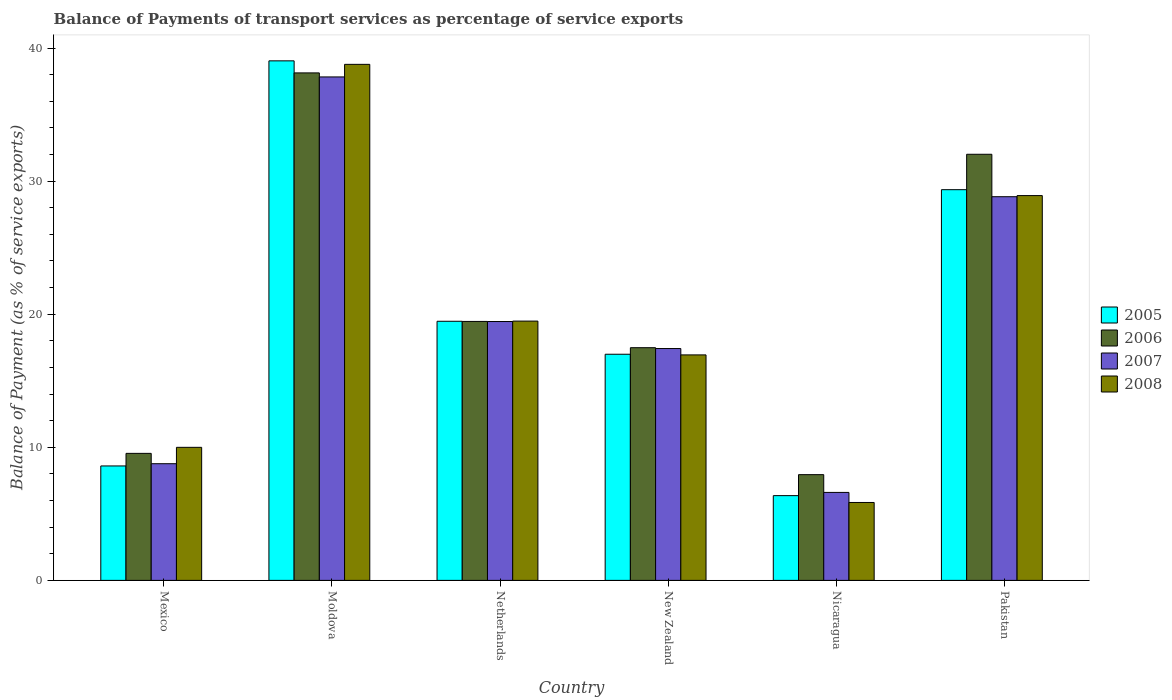How many different coloured bars are there?
Ensure brevity in your answer.  4. How many groups of bars are there?
Your response must be concise. 6. Are the number of bars per tick equal to the number of legend labels?
Make the answer very short. Yes. How many bars are there on the 1st tick from the left?
Your answer should be very brief. 4. What is the balance of payments of transport services in 2006 in Pakistan?
Provide a succinct answer. 32.02. Across all countries, what is the maximum balance of payments of transport services in 2006?
Your answer should be compact. 38.13. Across all countries, what is the minimum balance of payments of transport services in 2007?
Your answer should be compact. 6.61. In which country was the balance of payments of transport services in 2006 maximum?
Give a very brief answer. Moldova. In which country was the balance of payments of transport services in 2005 minimum?
Make the answer very short. Nicaragua. What is the total balance of payments of transport services in 2005 in the graph?
Your answer should be very brief. 119.83. What is the difference between the balance of payments of transport services in 2006 in New Zealand and that in Nicaragua?
Offer a terse response. 9.54. What is the difference between the balance of payments of transport services in 2005 in New Zealand and the balance of payments of transport services in 2006 in Moldova?
Provide a short and direct response. -21.14. What is the average balance of payments of transport services in 2007 per country?
Keep it short and to the point. 19.82. What is the difference between the balance of payments of transport services of/in 2008 and balance of payments of transport services of/in 2007 in Moldova?
Your response must be concise. 0.95. What is the ratio of the balance of payments of transport services in 2008 in Moldova to that in Pakistan?
Your answer should be very brief. 1.34. Is the balance of payments of transport services in 2006 in Moldova less than that in Netherlands?
Give a very brief answer. No. Is the difference between the balance of payments of transport services in 2008 in Moldova and Pakistan greater than the difference between the balance of payments of transport services in 2007 in Moldova and Pakistan?
Ensure brevity in your answer.  Yes. What is the difference between the highest and the second highest balance of payments of transport services in 2005?
Provide a succinct answer. -9.89. What is the difference between the highest and the lowest balance of payments of transport services in 2005?
Your response must be concise. 32.67. In how many countries, is the balance of payments of transport services in 2007 greater than the average balance of payments of transport services in 2007 taken over all countries?
Offer a very short reply. 2. Are all the bars in the graph horizontal?
Your answer should be very brief. No. How many countries are there in the graph?
Your answer should be very brief. 6. What is the difference between two consecutive major ticks on the Y-axis?
Offer a very short reply. 10. Are the values on the major ticks of Y-axis written in scientific E-notation?
Your response must be concise. No. Does the graph contain grids?
Make the answer very short. No. Where does the legend appear in the graph?
Ensure brevity in your answer.  Center right. How many legend labels are there?
Provide a succinct answer. 4. How are the legend labels stacked?
Offer a terse response. Vertical. What is the title of the graph?
Your answer should be very brief. Balance of Payments of transport services as percentage of service exports. What is the label or title of the Y-axis?
Provide a short and direct response. Balance of Payment (as % of service exports). What is the Balance of Payment (as % of service exports) in 2005 in Mexico?
Provide a succinct answer. 8.6. What is the Balance of Payment (as % of service exports) in 2006 in Mexico?
Ensure brevity in your answer.  9.54. What is the Balance of Payment (as % of service exports) of 2007 in Mexico?
Offer a terse response. 8.77. What is the Balance of Payment (as % of service exports) in 2008 in Mexico?
Ensure brevity in your answer.  10. What is the Balance of Payment (as % of service exports) of 2005 in Moldova?
Make the answer very short. 39.04. What is the Balance of Payment (as % of service exports) in 2006 in Moldova?
Your answer should be very brief. 38.13. What is the Balance of Payment (as % of service exports) in 2007 in Moldova?
Keep it short and to the point. 37.83. What is the Balance of Payment (as % of service exports) of 2008 in Moldova?
Your answer should be compact. 38.78. What is the Balance of Payment (as % of service exports) in 2005 in Netherlands?
Your answer should be compact. 19.47. What is the Balance of Payment (as % of service exports) in 2006 in Netherlands?
Offer a very short reply. 19.46. What is the Balance of Payment (as % of service exports) of 2007 in Netherlands?
Keep it short and to the point. 19.45. What is the Balance of Payment (as % of service exports) in 2008 in Netherlands?
Provide a short and direct response. 19.48. What is the Balance of Payment (as % of service exports) of 2005 in New Zealand?
Provide a short and direct response. 16.99. What is the Balance of Payment (as % of service exports) in 2006 in New Zealand?
Make the answer very short. 17.48. What is the Balance of Payment (as % of service exports) in 2007 in New Zealand?
Your response must be concise. 17.42. What is the Balance of Payment (as % of service exports) of 2008 in New Zealand?
Make the answer very short. 16.94. What is the Balance of Payment (as % of service exports) of 2005 in Nicaragua?
Offer a terse response. 6.37. What is the Balance of Payment (as % of service exports) in 2006 in Nicaragua?
Offer a very short reply. 7.95. What is the Balance of Payment (as % of service exports) in 2007 in Nicaragua?
Your answer should be compact. 6.61. What is the Balance of Payment (as % of service exports) in 2008 in Nicaragua?
Offer a terse response. 5.85. What is the Balance of Payment (as % of service exports) of 2005 in Pakistan?
Keep it short and to the point. 29.36. What is the Balance of Payment (as % of service exports) of 2006 in Pakistan?
Keep it short and to the point. 32.02. What is the Balance of Payment (as % of service exports) of 2007 in Pakistan?
Offer a very short reply. 28.83. What is the Balance of Payment (as % of service exports) in 2008 in Pakistan?
Give a very brief answer. 28.91. Across all countries, what is the maximum Balance of Payment (as % of service exports) in 2005?
Keep it short and to the point. 39.04. Across all countries, what is the maximum Balance of Payment (as % of service exports) in 2006?
Your response must be concise. 38.13. Across all countries, what is the maximum Balance of Payment (as % of service exports) of 2007?
Offer a terse response. 37.83. Across all countries, what is the maximum Balance of Payment (as % of service exports) of 2008?
Keep it short and to the point. 38.78. Across all countries, what is the minimum Balance of Payment (as % of service exports) of 2005?
Your response must be concise. 6.37. Across all countries, what is the minimum Balance of Payment (as % of service exports) of 2006?
Give a very brief answer. 7.95. Across all countries, what is the minimum Balance of Payment (as % of service exports) in 2007?
Your answer should be compact. 6.61. Across all countries, what is the minimum Balance of Payment (as % of service exports) of 2008?
Keep it short and to the point. 5.85. What is the total Balance of Payment (as % of service exports) of 2005 in the graph?
Your response must be concise. 119.83. What is the total Balance of Payment (as % of service exports) of 2006 in the graph?
Give a very brief answer. 124.59. What is the total Balance of Payment (as % of service exports) of 2007 in the graph?
Ensure brevity in your answer.  118.91. What is the total Balance of Payment (as % of service exports) of 2008 in the graph?
Your answer should be very brief. 119.97. What is the difference between the Balance of Payment (as % of service exports) in 2005 in Mexico and that in Moldova?
Give a very brief answer. -30.44. What is the difference between the Balance of Payment (as % of service exports) of 2006 in Mexico and that in Moldova?
Give a very brief answer. -28.59. What is the difference between the Balance of Payment (as % of service exports) of 2007 in Mexico and that in Moldova?
Provide a short and direct response. -29.06. What is the difference between the Balance of Payment (as % of service exports) in 2008 in Mexico and that in Moldova?
Your answer should be very brief. -28.78. What is the difference between the Balance of Payment (as % of service exports) of 2005 in Mexico and that in Netherlands?
Provide a succinct answer. -10.87. What is the difference between the Balance of Payment (as % of service exports) in 2006 in Mexico and that in Netherlands?
Ensure brevity in your answer.  -9.91. What is the difference between the Balance of Payment (as % of service exports) of 2007 in Mexico and that in Netherlands?
Offer a very short reply. -10.68. What is the difference between the Balance of Payment (as % of service exports) of 2008 in Mexico and that in Netherlands?
Give a very brief answer. -9.49. What is the difference between the Balance of Payment (as % of service exports) in 2005 in Mexico and that in New Zealand?
Make the answer very short. -8.39. What is the difference between the Balance of Payment (as % of service exports) of 2006 in Mexico and that in New Zealand?
Offer a terse response. -7.94. What is the difference between the Balance of Payment (as % of service exports) of 2007 in Mexico and that in New Zealand?
Offer a very short reply. -8.65. What is the difference between the Balance of Payment (as % of service exports) of 2008 in Mexico and that in New Zealand?
Make the answer very short. -6.95. What is the difference between the Balance of Payment (as % of service exports) of 2005 in Mexico and that in Nicaragua?
Keep it short and to the point. 2.23. What is the difference between the Balance of Payment (as % of service exports) in 2006 in Mexico and that in Nicaragua?
Your response must be concise. 1.6. What is the difference between the Balance of Payment (as % of service exports) in 2007 in Mexico and that in Nicaragua?
Keep it short and to the point. 2.16. What is the difference between the Balance of Payment (as % of service exports) of 2008 in Mexico and that in Nicaragua?
Give a very brief answer. 4.14. What is the difference between the Balance of Payment (as % of service exports) of 2005 in Mexico and that in Pakistan?
Offer a very short reply. -20.76. What is the difference between the Balance of Payment (as % of service exports) in 2006 in Mexico and that in Pakistan?
Keep it short and to the point. -22.47. What is the difference between the Balance of Payment (as % of service exports) of 2007 in Mexico and that in Pakistan?
Make the answer very short. -20.06. What is the difference between the Balance of Payment (as % of service exports) in 2008 in Mexico and that in Pakistan?
Your answer should be compact. -18.92. What is the difference between the Balance of Payment (as % of service exports) of 2005 in Moldova and that in Netherlands?
Ensure brevity in your answer.  19.57. What is the difference between the Balance of Payment (as % of service exports) of 2006 in Moldova and that in Netherlands?
Provide a succinct answer. 18.67. What is the difference between the Balance of Payment (as % of service exports) of 2007 in Moldova and that in Netherlands?
Your answer should be compact. 18.38. What is the difference between the Balance of Payment (as % of service exports) of 2008 in Moldova and that in Netherlands?
Offer a very short reply. 19.29. What is the difference between the Balance of Payment (as % of service exports) in 2005 in Moldova and that in New Zealand?
Make the answer very short. 22.05. What is the difference between the Balance of Payment (as % of service exports) of 2006 in Moldova and that in New Zealand?
Your response must be concise. 20.65. What is the difference between the Balance of Payment (as % of service exports) of 2007 in Moldova and that in New Zealand?
Your response must be concise. 20.41. What is the difference between the Balance of Payment (as % of service exports) in 2008 in Moldova and that in New Zealand?
Your answer should be very brief. 21.83. What is the difference between the Balance of Payment (as % of service exports) of 2005 in Moldova and that in Nicaragua?
Your answer should be compact. 32.67. What is the difference between the Balance of Payment (as % of service exports) in 2006 in Moldova and that in Nicaragua?
Ensure brevity in your answer.  30.19. What is the difference between the Balance of Payment (as % of service exports) in 2007 in Moldova and that in Nicaragua?
Offer a very short reply. 31.22. What is the difference between the Balance of Payment (as % of service exports) of 2008 in Moldova and that in Nicaragua?
Make the answer very short. 32.92. What is the difference between the Balance of Payment (as % of service exports) of 2005 in Moldova and that in Pakistan?
Offer a very short reply. 9.68. What is the difference between the Balance of Payment (as % of service exports) in 2006 in Moldova and that in Pakistan?
Give a very brief answer. 6.11. What is the difference between the Balance of Payment (as % of service exports) of 2007 in Moldova and that in Pakistan?
Offer a terse response. 9. What is the difference between the Balance of Payment (as % of service exports) of 2008 in Moldova and that in Pakistan?
Give a very brief answer. 9.86. What is the difference between the Balance of Payment (as % of service exports) of 2005 in Netherlands and that in New Zealand?
Provide a succinct answer. 2.48. What is the difference between the Balance of Payment (as % of service exports) of 2006 in Netherlands and that in New Zealand?
Offer a very short reply. 1.97. What is the difference between the Balance of Payment (as % of service exports) in 2007 in Netherlands and that in New Zealand?
Give a very brief answer. 2.03. What is the difference between the Balance of Payment (as % of service exports) of 2008 in Netherlands and that in New Zealand?
Offer a terse response. 2.54. What is the difference between the Balance of Payment (as % of service exports) of 2005 in Netherlands and that in Nicaragua?
Give a very brief answer. 13.1. What is the difference between the Balance of Payment (as % of service exports) in 2006 in Netherlands and that in Nicaragua?
Offer a terse response. 11.51. What is the difference between the Balance of Payment (as % of service exports) of 2007 in Netherlands and that in Nicaragua?
Your response must be concise. 12.84. What is the difference between the Balance of Payment (as % of service exports) of 2008 in Netherlands and that in Nicaragua?
Your response must be concise. 13.63. What is the difference between the Balance of Payment (as % of service exports) in 2005 in Netherlands and that in Pakistan?
Make the answer very short. -9.89. What is the difference between the Balance of Payment (as % of service exports) in 2006 in Netherlands and that in Pakistan?
Offer a terse response. -12.56. What is the difference between the Balance of Payment (as % of service exports) of 2007 in Netherlands and that in Pakistan?
Ensure brevity in your answer.  -9.38. What is the difference between the Balance of Payment (as % of service exports) of 2008 in Netherlands and that in Pakistan?
Provide a short and direct response. -9.43. What is the difference between the Balance of Payment (as % of service exports) of 2005 in New Zealand and that in Nicaragua?
Ensure brevity in your answer.  10.62. What is the difference between the Balance of Payment (as % of service exports) in 2006 in New Zealand and that in Nicaragua?
Your answer should be very brief. 9.54. What is the difference between the Balance of Payment (as % of service exports) of 2007 in New Zealand and that in Nicaragua?
Ensure brevity in your answer.  10.81. What is the difference between the Balance of Payment (as % of service exports) in 2008 in New Zealand and that in Nicaragua?
Your answer should be compact. 11.09. What is the difference between the Balance of Payment (as % of service exports) in 2005 in New Zealand and that in Pakistan?
Provide a succinct answer. -12.37. What is the difference between the Balance of Payment (as % of service exports) of 2006 in New Zealand and that in Pakistan?
Your answer should be very brief. -14.53. What is the difference between the Balance of Payment (as % of service exports) of 2007 in New Zealand and that in Pakistan?
Provide a short and direct response. -11.41. What is the difference between the Balance of Payment (as % of service exports) of 2008 in New Zealand and that in Pakistan?
Your answer should be compact. -11.97. What is the difference between the Balance of Payment (as % of service exports) of 2005 in Nicaragua and that in Pakistan?
Offer a very short reply. -22.99. What is the difference between the Balance of Payment (as % of service exports) of 2006 in Nicaragua and that in Pakistan?
Provide a short and direct response. -24.07. What is the difference between the Balance of Payment (as % of service exports) in 2007 in Nicaragua and that in Pakistan?
Make the answer very short. -22.22. What is the difference between the Balance of Payment (as % of service exports) of 2008 in Nicaragua and that in Pakistan?
Ensure brevity in your answer.  -23.06. What is the difference between the Balance of Payment (as % of service exports) of 2005 in Mexico and the Balance of Payment (as % of service exports) of 2006 in Moldova?
Your answer should be compact. -29.53. What is the difference between the Balance of Payment (as % of service exports) of 2005 in Mexico and the Balance of Payment (as % of service exports) of 2007 in Moldova?
Provide a succinct answer. -29.23. What is the difference between the Balance of Payment (as % of service exports) in 2005 in Mexico and the Balance of Payment (as % of service exports) in 2008 in Moldova?
Offer a terse response. -30.18. What is the difference between the Balance of Payment (as % of service exports) in 2006 in Mexico and the Balance of Payment (as % of service exports) in 2007 in Moldova?
Ensure brevity in your answer.  -28.29. What is the difference between the Balance of Payment (as % of service exports) of 2006 in Mexico and the Balance of Payment (as % of service exports) of 2008 in Moldova?
Provide a short and direct response. -29.23. What is the difference between the Balance of Payment (as % of service exports) in 2007 in Mexico and the Balance of Payment (as % of service exports) in 2008 in Moldova?
Keep it short and to the point. -30.01. What is the difference between the Balance of Payment (as % of service exports) in 2005 in Mexico and the Balance of Payment (as % of service exports) in 2006 in Netherlands?
Give a very brief answer. -10.86. What is the difference between the Balance of Payment (as % of service exports) in 2005 in Mexico and the Balance of Payment (as % of service exports) in 2007 in Netherlands?
Your answer should be compact. -10.85. What is the difference between the Balance of Payment (as % of service exports) of 2005 in Mexico and the Balance of Payment (as % of service exports) of 2008 in Netherlands?
Your answer should be very brief. -10.88. What is the difference between the Balance of Payment (as % of service exports) in 2006 in Mexico and the Balance of Payment (as % of service exports) in 2007 in Netherlands?
Provide a succinct answer. -9.91. What is the difference between the Balance of Payment (as % of service exports) of 2006 in Mexico and the Balance of Payment (as % of service exports) of 2008 in Netherlands?
Your response must be concise. -9.94. What is the difference between the Balance of Payment (as % of service exports) of 2007 in Mexico and the Balance of Payment (as % of service exports) of 2008 in Netherlands?
Ensure brevity in your answer.  -10.72. What is the difference between the Balance of Payment (as % of service exports) in 2005 in Mexico and the Balance of Payment (as % of service exports) in 2006 in New Zealand?
Your answer should be very brief. -8.89. What is the difference between the Balance of Payment (as % of service exports) in 2005 in Mexico and the Balance of Payment (as % of service exports) in 2007 in New Zealand?
Give a very brief answer. -8.82. What is the difference between the Balance of Payment (as % of service exports) in 2005 in Mexico and the Balance of Payment (as % of service exports) in 2008 in New Zealand?
Your response must be concise. -8.35. What is the difference between the Balance of Payment (as % of service exports) of 2006 in Mexico and the Balance of Payment (as % of service exports) of 2007 in New Zealand?
Keep it short and to the point. -7.88. What is the difference between the Balance of Payment (as % of service exports) of 2006 in Mexico and the Balance of Payment (as % of service exports) of 2008 in New Zealand?
Give a very brief answer. -7.4. What is the difference between the Balance of Payment (as % of service exports) of 2007 in Mexico and the Balance of Payment (as % of service exports) of 2008 in New Zealand?
Offer a very short reply. -8.18. What is the difference between the Balance of Payment (as % of service exports) of 2005 in Mexico and the Balance of Payment (as % of service exports) of 2006 in Nicaragua?
Your response must be concise. 0.65. What is the difference between the Balance of Payment (as % of service exports) of 2005 in Mexico and the Balance of Payment (as % of service exports) of 2007 in Nicaragua?
Give a very brief answer. 1.99. What is the difference between the Balance of Payment (as % of service exports) in 2005 in Mexico and the Balance of Payment (as % of service exports) in 2008 in Nicaragua?
Make the answer very short. 2.74. What is the difference between the Balance of Payment (as % of service exports) of 2006 in Mexico and the Balance of Payment (as % of service exports) of 2007 in Nicaragua?
Your answer should be very brief. 2.93. What is the difference between the Balance of Payment (as % of service exports) of 2006 in Mexico and the Balance of Payment (as % of service exports) of 2008 in Nicaragua?
Give a very brief answer. 3.69. What is the difference between the Balance of Payment (as % of service exports) in 2007 in Mexico and the Balance of Payment (as % of service exports) in 2008 in Nicaragua?
Offer a very short reply. 2.91. What is the difference between the Balance of Payment (as % of service exports) of 2005 in Mexico and the Balance of Payment (as % of service exports) of 2006 in Pakistan?
Keep it short and to the point. -23.42. What is the difference between the Balance of Payment (as % of service exports) in 2005 in Mexico and the Balance of Payment (as % of service exports) in 2007 in Pakistan?
Keep it short and to the point. -20.23. What is the difference between the Balance of Payment (as % of service exports) of 2005 in Mexico and the Balance of Payment (as % of service exports) of 2008 in Pakistan?
Make the answer very short. -20.32. What is the difference between the Balance of Payment (as % of service exports) of 2006 in Mexico and the Balance of Payment (as % of service exports) of 2007 in Pakistan?
Provide a short and direct response. -19.29. What is the difference between the Balance of Payment (as % of service exports) of 2006 in Mexico and the Balance of Payment (as % of service exports) of 2008 in Pakistan?
Offer a very short reply. -19.37. What is the difference between the Balance of Payment (as % of service exports) of 2007 in Mexico and the Balance of Payment (as % of service exports) of 2008 in Pakistan?
Your answer should be very brief. -20.15. What is the difference between the Balance of Payment (as % of service exports) in 2005 in Moldova and the Balance of Payment (as % of service exports) in 2006 in Netherlands?
Give a very brief answer. 19.58. What is the difference between the Balance of Payment (as % of service exports) in 2005 in Moldova and the Balance of Payment (as % of service exports) in 2007 in Netherlands?
Ensure brevity in your answer.  19.59. What is the difference between the Balance of Payment (as % of service exports) of 2005 in Moldova and the Balance of Payment (as % of service exports) of 2008 in Netherlands?
Give a very brief answer. 19.56. What is the difference between the Balance of Payment (as % of service exports) of 2006 in Moldova and the Balance of Payment (as % of service exports) of 2007 in Netherlands?
Your response must be concise. 18.68. What is the difference between the Balance of Payment (as % of service exports) of 2006 in Moldova and the Balance of Payment (as % of service exports) of 2008 in Netherlands?
Keep it short and to the point. 18.65. What is the difference between the Balance of Payment (as % of service exports) in 2007 in Moldova and the Balance of Payment (as % of service exports) in 2008 in Netherlands?
Make the answer very short. 18.35. What is the difference between the Balance of Payment (as % of service exports) in 2005 in Moldova and the Balance of Payment (as % of service exports) in 2006 in New Zealand?
Keep it short and to the point. 21.55. What is the difference between the Balance of Payment (as % of service exports) in 2005 in Moldova and the Balance of Payment (as % of service exports) in 2007 in New Zealand?
Make the answer very short. 21.62. What is the difference between the Balance of Payment (as % of service exports) of 2005 in Moldova and the Balance of Payment (as % of service exports) of 2008 in New Zealand?
Offer a terse response. 22.09. What is the difference between the Balance of Payment (as % of service exports) of 2006 in Moldova and the Balance of Payment (as % of service exports) of 2007 in New Zealand?
Keep it short and to the point. 20.71. What is the difference between the Balance of Payment (as % of service exports) of 2006 in Moldova and the Balance of Payment (as % of service exports) of 2008 in New Zealand?
Offer a terse response. 21.19. What is the difference between the Balance of Payment (as % of service exports) of 2007 in Moldova and the Balance of Payment (as % of service exports) of 2008 in New Zealand?
Your answer should be compact. 20.89. What is the difference between the Balance of Payment (as % of service exports) in 2005 in Moldova and the Balance of Payment (as % of service exports) in 2006 in Nicaragua?
Make the answer very short. 31.09. What is the difference between the Balance of Payment (as % of service exports) in 2005 in Moldova and the Balance of Payment (as % of service exports) in 2007 in Nicaragua?
Provide a short and direct response. 32.43. What is the difference between the Balance of Payment (as % of service exports) in 2005 in Moldova and the Balance of Payment (as % of service exports) in 2008 in Nicaragua?
Provide a succinct answer. 33.18. What is the difference between the Balance of Payment (as % of service exports) in 2006 in Moldova and the Balance of Payment (as % of service exports) in 2007 in Nicaragua?
Your answer should be compact. 31.52. What is the difference between the Balance of Payment (as % of service exports) of 2006 in Moldova and the Balance of Payment (as % of service exports) of 2008 in Nicaragua?
Ensure brevity in your answer.  32.28. What is the difference between the Balance of Payment (as % of service exports) of 2007 in Moldova and the Balance of Payment (as % of service exports) of 2008 in Nicaragua?
Your answer should be very brief. 31.98. What is the difference between the Balance of Payment (as % of service exports) of 2005 in Moldova and the Balance of Payment (as % of service exports) of 2006 in Pakistan?
Your answer should be very brief. 7.02. What is the difference between the Balance of Payment (as % of service exports) of 2005 in Moldova and the Balance of Payment (as % of service exports) of 2007 in Pakistan?
Offer a very short reply. 10.21. What is the difference between the Balance of Payment (as % of service exports) of 2005 in Moldova and the Balance of Payment (as % of service exports) of 2008 in Pakistan?
Your answer should be very brief. 10.12. What is the difference between the Balance of Payment (as % of service exports) of 2006 in Moldova and the Balance of Payment (as % of service exports) of 2007 in Pakistan?
Your answer should be very brief. 9.3. What is the difference between the Balance of Payment (as % of service exports) in 2006 in Moldova and the Balance of Payment (as % of service exports) in 2008 in Pakistan?
Your answer should be very brief. 9.22. What is the difference between the Balance of Payment (as % of service exports) in 2007 in Moldova and the Balance of Payment (as % of service exports) in 2008 in Pakistan?
Offer a terse response. 8.92. What is the difference between the Balance of Payment (as % of service exports) of 2005 in Netherlands and the Balance of Payment (as % of service exports) of 2006 in New Zealand?
Give a very brief answer. 1.99. What is the difference between the Balance of Payment (as % of service exports) in 2005 in Netherlands and the Balance of Payment (as % of service exports) in 2007 in New Zealand?
Your answer should be very brief. 2.05. What is the difference between the Balance of Payment (as % of service exports) of 2005 in Netherlands and the Balance of Payment (as % of service exports) of 2008 in New Zealand?
Offer a terse response. 2.53. What is the difference between the Balance of Payment (as % of service exports) in 2006 in Netherlands and the Balance of Payment (as % of service exports) in 2007 in New Zealand?
Offer a terse response. 2.04. What is the difference between the Balance of Payment (as % of service exports) of 2006 in Netherlands and the Balance of Payment (as % of service exports) of 2008 in New Zealand?
Make the answer very short. 2.51. What is the difference between the Balance of Payment (as % of service exports) of 2007 in Netherlands and the Balance of Payment (as % of service exports) of 2008 in New Zealand?
Give a very brief answer. 2.51. What is the difference between the Balance of Payment (as % of service exports) of 2005 in Netherlands and the Balance of Payment (as % of service exports) of 2006 in Nicaragua?
Keep it short and to the point. 11.52. What is the difference between the Balance of Payment (as % of service exports) of 2005 in Netherlands and the Balance of Payment (as % of service exports) of 2007 in Nicaragua?
Make the answer very short. 12.86. What is the difference between the Balance of Payment (as % of service exports) of 2005 in Netherlands and the Balance of Payment (as % of service exports) of 2008 in Nicaragua?
Provide a short and direct response. 13.62. What is the difference between the Balance of Payment (as % of service exports) of 2006 in Netherlands and the Balance of Payment (as % of service exports) of 2007 in Nicaragua?
Keep it short and to the point. 12.85. What is the difference between the Balance of Payment (as % of service exports) of 2006 in Netherlands and the Balance of Payment (as % of service exports) of 2008 in Nicaragua?
Make the answer very short. 13.6. What is the difference between the Balance of Payment (as % of service exports) in 2007 in Netherlands and the Balance of Payment (as % of service exports) in 2008 in Nicaragua?
Give a very brief answer. 13.6. What is the difference between the Balance of Payment (as % of service exports) of 2005 in Netherlands and the Balance of Payment (as % of service exports) of 2006 in Pakistan?
Provide a short and direct response. -12.55. What is the difference between the Balance of Payment (as % of service exports) in 2005 in Netherlands and the Balance of Payment (as % of service exports) in 2007 in Pakistan?
Provide a short and direct response. -9.36. What is the difference between the Balance of Payment (as % of service exports) in 2005 in Netherlands and the Balance of Payment (as % of service exports) in 2008 in Pakistan?
Offer a terse response. -9.44. What is the difference between the Balance of Payment (as % of service exports) in 2006 in Netherlands and the Balance of Payment (as % of service exports) in 2007 in Pakistan?
Your answer should be very brief. -9.37. What is the difference between the Balance of Payment (as % of service exports) in 2006 in Netherlands and the Balance of Payment (as % of service exports) in 2008 in Pakistan?
Your answer should be very brief. -9.46. What is the difference between the Balance of Payment (as % of service exports) of 2007 in Netherlands and the Balance of Payment (as % of service exports) of 2008 in Pakistan?
Give a very brief answer. -9.46. What is the difference between the Balance of Payment (as % of service exports) of 2005 in New Zealand and the Balance of Payment (as % of service exports) of 2006 in Nicaragua?
Provide a short and direct response. 9.05. What is the difference between the Balance of Payment (as % of service exports) of 2005 in New Zealand and the Balance of Payment (as % of service exports) of 2007 in Nicaragua?
Keep it short and to the point. 10.38. What is the difference between the Balance of Payment (as % of service exports) of 2005 in New Zealand and the Balance of Payment (as % of service exports) of 2008 in Nicaragua?
Provide a succinct answer. 11.14. What is the difference between the Balance of Payment (as % of service exports) in 2006 in New Zealand and the Balance of Payment (as % of service exports) in 2007 in Nicaragua?
Provide a succinct answer. 10.87. What is the difference between the Balance of Payment (as % of service exports) of 2006 in New Zealand and the Balance of Payment (as % of service exports) of 2008 in Nicaragua?
Keep it short and to the point. 11.63. What is the difference between the Balance of Payment (as % of service exports) of 2007 in New Zealand and the Balance of Payment (as % of service exports) of 2008 in Nicaragua?
Keep it short and to the point. 11.57. What is the difference between the Balance of Payment (as % of service exports) in 2005 in New Zealand and the Balance of Payment (as % of service exports) in 2006 in Pakistan?
Offer a terse response. -15.03. What is the difference between the Balance of Payment (as % of service exports) of 2005 in New Zealand and the Balance of Payment (as % of service exports) of 2007 in Pakistan?
Provide a short and direct response. -11.84. What is the difference between the Balance of Payment (as % of service exports) in 2005 in New Zealand and the Balance of Payment (as % of service exports) in 2008 in Pakistan?
Provide a succinct answer. -11.92. What is the difference between the Balance of Payment (as % of service exports) in 2006 in New Zealand and the Balance of Payment (as % of service exports) in 2007 in Pakistan?
Your response must be concise. -11.35. What is the difference between the Balance of Payment (as % of service exports) of 2006 in New Zealand and the Balance of Payment (as % of service exports) of 2008 in Pakistan?
Make the answer very short. -11.43. What is the difference between the Balance of Payment (as % of service exports) of 2007 in New Zealand and the Balance of Payment (as % of service exports) of 2008 in Pakistan?
Give a very brief answer. -11.49. What is the difference between the Balance of Payment (as % of service exports) of 2005 in Nicaragua and the Balance of Payment (as % of service exports) of 2006 in Pakistan?
Your answer should be compact. -25.65. What is the difference between the Balance of Payment (as % of service exports) in 2005 in Nicaragua and the Balance of Payment (as % of service exports) in 2007 in Pakistan?
Provide a short and direct response. -22.46. What is the difference between the Balance of Payment (as % of service exports) of 2005 in Nicaragua and the Balance of Payment (as % of service exports) of 2008 in Pakistan?
Make the answer very short. -22.55. What is the difference between the Balance of Payment (as % of service exports) in 2006 in Nicaragua and the Balance of Payment (as % of service exports) in 2007 in Pakistan?
Keep it short and to the point. -20.89. What is the difference between the Balance of Payment (as % of service exports) in 2006 in Nicaragua and the Balance of Payment (as % of service exports) in 2008 in Pakistan?
Give a very brief answer. -20.97. What is the difference between the Balance of Payment (as % of service exports) in 2007 in Nicaragua and the Balance of Payment (as % of service exports) in 2008 in Pakistan?
Ensure brevity in your answer.  -22.3. What is the average Balance of Payment (as % of service exports) of 2005 per country?
Offer a terse response. 19.97. What is the average Balance of Payment (as % of service exports) of 2006 per country?
Offer a terse response. 20.76. What is the average Balance of Payment (as % of service exports) of 2007 per country?
Make the answer very short. 19.82. What is the average Balance of Payment (as % of service exports) in 2008 per country?
Make the answer very short. 20. What is the difference between the Balance of Payment (as % of service exports) of 2005 and Balance of Payment (as % of service exports) of 2006 in Mexico?
Provide a short and direct response. -0.95. What is the difference between the Balance of Payment (as % of service exports) of 2005 and Balance of Payment (as % of service exports) of 2007 in Mexico?
Make the answer very short. -0.17. What is the difference between the Balance of Payment (as % of service exports) in 2005 and Balance of Payment (as % of service exports) in 2008 in Mexico?
Make the answer very short. -1.4. What is the difference between the Balance of Payment (as % of service exports) of 2006 and Balance of Payment (as % of service exports) of 2007 in Mexico?
Your response must be concise. 0.78. What is the difference between the Balance of Payment (as % of service exports) of 2006 and Balance of Payment (as % of service exports) of 2008 in Mexico?
Ensure brevity in your answer.  -0.45. What is the difference between the Balance of Payment (as % of service exports) of 2007 and Balance of Payment (as % of service exports) of 2008 in Mexico?
Your response must be concise. -1.23. What is the difference between the Balance of Payment (as % of service exports) of 2005 and Balance of Payment (as % of service exports) of 2006 in Moldova?
Provide a short and direct response. 0.91. What is the difference between the Balance of Payment (as % of service exports) in 2005 and Balance of Payment (as % of service exports) in 2007 in Moldova?
Provide a short and direct response. 1.21. What is the difference between the Balance of Payment (as % of service exports) in 2005 and Balance of Payment (as % of service exports) in 2008 in Moldova?
Provide a short and direct response. 0.26. What is the difference between the Balance of Payment (as % of service exports) of 2006 and Balance of Payment (as % of service exports) of 2007 in Moldova?
Offer a terse response. 0.3. What is the difference between the Balance of Payment (as % of service exports) in 2006 and Balance of Payment (as % of service exports) in 2008 in Moldova?
Provide a succinct answer. -0.64. What is the difference between the Balance of Payment (as % of service exports) in 2007 and Balance of Payment (as % of service exports) in 2008 in Moldova?
Your answer should be very brief. -0.95. What is the difference between the Balance of Payment (as % of service exports) in 2005 and Balance of Payment (as % of service exports) in 2006 in Netherlands?
Your response must be concise. 0.01. What is the difference between the Balance of Payment (as % of service exports) of 2005 and Balance of Payment (as % of service exports) of 2007 in Netherlands?
Offer a terse response. 0.02. What is the difference between the Balance of Payment (as % of service exports) of 2005 and Balance of Payment (as % of service exports) of 2008 in Netherlands?
Make the answer very short. -0.01. What is the difference between the Balance of Payment (as % of service exports) of 2006 and Balance of Payment (as % of service exports) of 2007 in Netherlands?
Ensure brevity in your answer.  0.01. What is the difference between the Balance of Payment (as % of service exports) of 2006 and Balance of Payment (as % of service exports) of 2008 in Netherlands?
Ensure brevity in your answer.  -0.03. What is the difference between the Balance of Payment (as % of service exports) of 2007 and Balance of Payment (as % of service exports) of 2008 in Netherlands?
Make the answer very short. -0.03. What is the difference between the Balance of Payment (as % of service exports) of 2005 and Balance of Payment (as % of service exports) of 2006 in New Zealand?
Your answer should be very brief. -0.49. What is the difference between the Balance of Payment (as % of service exports) in 2005 and Balance of Payment (as % of service exports) in 2007 in New Zealand?
Offer a terse response. -0.43. What is the difference between the Balance of Payment (as % of service exports) in 2005 and Balance of Payment (as % of service exports) in 2008 in New Zealand?
Offer a terse response. 0.05. What is the difference between the Balance of Payment (as % of service exports) of 2006 and Balance of Payment (as % of service exports) of 2007 in New Zealand?
Your answer should be very brief. 0.06. What is the difference between the Balance of Payment (as % of service exports) in 2006 and Balance of Payment (as % of service exports) in 2008 in New Zealand?
Offer a terse response. 0.54. What is the difference between the Balance of Payment (as % of service exports) of 2007 and Balance of Payment (as % of service exports) of 2008 in New Zealand?
Keep it short and to the point. 0.48. What is the difference between the Balance of Payment (as % of service exports) in 2005 and Balance of Payment (as % of service exports) in 2006 in Nicaragua?
Your response must be concise. -1.58. What is the difference between the Balance of Payment (as % of service exports) in 2005 and Balance of Payment (as % of service exports) in 2007 in Nicaragua?
Your answer should be very brief. -0.24. What is the difference between the Balance of Payment (as % of service exports) in 2005 and Balance of Payment (as % of service exports) in 2008 in Nicaragua?
Your response must be concise. 0.51. What is the difference between the Balance of Payment (as % of service exports) of 2006 and Balance of Payment (as % of service exports) of 2007 in Nicaragua?
Your response must be concise. 1.33. What is the difference between the Balance of Payment (as % of service exports) in 2006 and Balance of Payment (as % of service exports) in 2008 in Nicaragua?
Provide a succinct answer. 2.09. What is the difference between the Balance of Payment (as % of service exports) of 2007 and Balance of Payment (as % of service exports) of 2008 in Nicaragua?
Provide a succinct answer. 0.76. What is the difference between the Balance of Payment (as % of service exports) of 2005 and Balance of Payment (as % of service exports) of 2006 in Pakistan?
Keep it short and to the point. -2.66. What is the difference between the Balance of Payment (as % of service exports) in 2005 and Balance of Payment (as % of service exports) in 2007 in Pakistan?
Your answer should be very brief. 0.53. What is the difference between the Balance of Payment (as % of service exports) of 2005 and Balance of Payment (as % of service exports) of 2008 in Pakistan?
Provide a succinct answer. 0.44. What is the difference between the Balance of Payment (as % of service exports) in 2006 and Balance of Payment (as % of service exports) in 2007 in Pakistan?
Your answer should be very brief. 3.19. What is the difference between the Balance of Payment (as % of service exports) of 2006 and Balance of Payment (as % of service exports) of 2008 in Pakistan?
Offer a terse response. 3.1. What is the difference between the Balance of Payment (as % of service exports) of 2007 and Balance of Payment (as % of service exports) of 2008 in Pakistan?
Make the answer very short. -0.08. What is the ratio of the Balance of Payment (as % of service exports) of 2005 in Mexico to that in Moldova?
Provide a short and direct response. 0.22. What is the ratio of the Balance of Payment (as % of service exports) of 2006 in Mexico to that in Moldova?
Your response must be concise. 0.25. What is the ratio of the Balance of Payment (as % of service exports) in 2007 in Mexico to that in Moldova?
Offer a terse response. 0.23. What is the ratio of the Balance of Payment (as % of service exports) in 2008 in Mexico to that in Moldova?
Provide a short and direct response. 0.26. What is the ratio of the Balance of Payment (as % of service exports) of 2005 in Mexico to that in Netherlands?
Provide a succinct answer. 0.44. What is the ratio of the Balance of Payment (as % of service exports) of 2006 in Mexico to that in Netherlands?
Your answer should be compact. 0.49. What is the ratio of the Balance of Payment (as % of service exports) of 2007 in Mexico to that in Netherlands?
Make the answer very short. 0.45. What is the ratio of the Balance of Payment (as % of service exports) of 2008 in Mexico to that in Netherlands?
Your answer should be very brief. 0.51. What is the ratio of the Balance of Payment (as % of service exports) in 2005 in Mexico to that in New Zealand?
Provide a short and direct response. 0.51. What is the ratio of the Balance of Payment (as % of service exports) in 2006 in Mexico to that in New Zealand?
Your answer should be very brief. 0.55. What is the ratio of the Balance of Payment (as % of service exports) in 2007 in Mexico to that in New Zealand?
Offer a very short reply. 0.5. What is the ratio of the Balance of Payment (as % of service exports) in 2008 in Mexico to that in New Zealand?
Ensure brevity in your answer.  0.59. What is the ratio of the Balance of Payment (as % of service exports) in 2005 in Mexico to that in Nicaragua?
Offer a terse response. 1.35. What is the ratio of the Balance of Payment (as % of service exports) of 2006 in Mexico to that in Nicaragua?
Give a very brief answer. 1.2. What is the ratio of the Balance of Payment (as % of service exports) in 2007 in Mexico to that in Nicaragua?
Offer a terse response. 1.33. What is the ratio of the Balance of Payment (as % of service exports) of 2008 in Mexico to that in Nicaragua?
Provide a succinct answer. 1.71. What is the ratio of the Balance of Payment (as % of service exports) in 2005 in Mexico to that in Pakistan?
Offer a terse response. 0.29. What is the ratio of the Balance of Payment (as % of service exports) in 2006 in Mexico to that in Pakistan?
Your answer should be compact. 0.3. What is the ratio of the Balance of Payment (as % of service exports) of 2007 in Mexico to that in Pakistan?
Give a very brief answer. 0.3. What is the ratio of the Balance of Payment (as % of service exports) in 2008 in Mexico to that in Pakistan?
Provide a short and direct response. 0.35. What is the ratio of the Balance of Payment (as % of service exports) of 2005 in Moldova to that in Netherlands?
Offer a very short reply. 2.01. What is the ratio of the Balance of Payment (as % of service exports) of 2006 in Moldova to that in Netherlands?
Provide a succinct answer. 1.96. What is the ratio of the Balance of Payment (as % of service exports) in 2007 in Moldova to that in Netherlands?
Make the answer very short. 1.94. What is the ratio of the Balance of Payment (as % of service exports) of 2008 in Moldova to that in Netherlands?
Keep it short and to the point. 1.99. What is the ratio of the Balance of Payment (as % of service exports) of 2005 in Moldova to that in New Zealand?
Provide a short and direct response. 2.3. What is the ratio of the Balance of Payment (as % of service exports) of 2006 in Moldova to that in New Zealand?
Offer a terse response. 2.18. What is the ratio of the Balance of Payment (as % of service exports) in 2007 in Moldova to that in New Zealand?
Offer a terse response. 2.17. What is the ratio of the Balance of Payment (as % of service exports) of 2008 in Moldova to that in New Zealand?
Provide a succinct answer. 2.29. What is the ratio of the Balance of Payment (as % of service exports) of 2005 in Moldova to that in Nicaragua?
Offer a terse response. 6.13. What is the ratio of the Balance of Payment (as % of service exports) in 2006 in Moldova to that in Nicaragua?
Your response must be concise. 4.8. What is the ratio of the Balance of Payment (as % of service exports) in 2007 in Moldova to that in Nicaragua?
Your answer should be compact. 5.72. What is the ratio of the Balance of Payment (as % of service exports) of 2008 in Moldova to that in Nicaragua?
Keep it short and to the point. 6.62. What is the ratio of the Balance of Payment (as % of service exports) in 2005 in Moldova to that in Pakistan?
Your response must be concise. 1.33. What is the ratio of the Balance of Payment (as % of service exports) of 2006 in Moldova to that in Pakistan?
Offer a very short reply. 1.19. What is the ratio of the Balance of Payment (as % of service exports) of 2007 in Moldova to that in Pakistan?
Provide a short and direct response. 1.31. What is the ratio of the Balance of Payment (as % of service exports) of 2008 in Moldova to that in Pakistan?
Keep it short and to the point. 1.34. What is the ratio of the Balance of Payment (as % of service exports) of 2005 in Netherlands to that in New Zealand?
Your response must be concise. 1.15. What is the ratio of the Balance of Payment (as % of service exports) of 2006 in Netherlands to that in New Zealand?
Keep it short and to the point. 1.11. What is the ratio of the Balance of Payment (as % of service exports) of 2007 in Netherlands to that in New Zealand?
Make the answer very short. 1.12. What is the ratio of the Balance of Payment (as % of service exports) of 2008 in Netherlands to that in New Zealand?
Your answer should be compact. 1.15. What is the ratio of the Balance of Payment (as % of service exports) of 2005 in Netherlands to that in Nicaragua?
Your answer should be compact. 3.06. What is the ratio of the Balance of Payment (as % of service exports) in 2006 in Netherlands to that in Nicaragua?
Give a very brief answer. 2.45. What is the ratio of the Balance of Payment (as % of service exports) in 2007 in Netherlands to that in Nicaragua?
Provide a short and direct response. 2.94. What is the ratio of the Balance of Payment (as % of service exports) of 2008 in Netherlands to that in Nicaragua?
Your answer should be compact. 3.33. What is the ratio of the Balance of Payment (as % of service exports) of 2005 in Netherlands to that in Pakistan?
Offer a very short reply. 0.66. What is the ratio of the Balance of Payment (as % of service exports) of 2006 in Netherlands to that in Pakistan?
Offer a terse response. 0.61. What is the ratio of the Balance of Payment (as % of service exports) in 2007 in Netherlands to that in Pakistan?
Your answer should be very brief. 0.67. What is the ratio of the Balance of Payment (as % of service exports) of 2008 in Netherlands to that in Pakistan?
Give a very brief answer. 0.67. What is the ratio of the Balance of Payment (as % of service exports) in 2005 in New Zealand to that in Nicaragua?
Ensure brevity in your answer.  2.67. What is the ratio of the Balance of Payment (as % of service exports) of 2006 in New Zealand to that in Nicaragua?
Keep it short and to the point. 2.2. What is the ratio of the Balance of Payment (as % of service exports) of 2007 in New Zealand to that in Nicaragua?
Give a very brief answer. 2.64. What is the ratio of the Balance of Payment (as % of service exports) in 2008 in New Zealand to that in Nicaragua?
Give a very brief answer. 2.89. What is the ratio of the Balance of Payment (as % of service exports) of 2005 in New Zealand to that in Pakistan?
Your answer should be compact. 0.58. What is the ratio of the Balance of Payment (as % of service exports) of 2006 in New Zealand to that in Pakistan?
Give a very brief answer. 0.55. What is the ratio of the Balance of Payment (as % of service exports) of 2007 in New Zealand to that in Pakistan?
Keep it short and to the point. 0.6. What is the ratio of the Balance of Payment (as % of service exports) of 2008 in New Zealand to that in Pakistan?
Your answer should be very brief. 0.59. What is the ratio of the Balance of Payment (as % of service exports) in 2005 in Nicaragua to that in Pakistan?
Your answer should be compact. 0.22. What is the ratio of the Balance of Payment (as % of service exports) in 2006 in Nicaragua to that in Pakistan?
Offer a terse response. 0.25. What is the ratio of the Balance of Payment (as % of service exports) of 2007 in Nicaragua to that in Pakistan?
Give a very brief answer. 0.23. What is the ratio of the Balance of Payment (as % of service exports) of 2008 in Nicaragua to that in Pakistan?
Ensure brevity in your answer.  0.2. What is the difference between the highest and the second highest Balance of Payment (as % of service exports) in 2005?
Your answer should be compact. 9.68. What is the difference between the highest and the second highest Balance of Payment (as % of service exports) in 2006?
Provide a succinct answer. 6.11. What is the difference between the highest and the second highest Balance of Payment (as % of service exports) in 2007?
Provide a succinct answer. 9. What is the difference between the highest and the second highest Balance of Payment (as % of service exports) in 2008?
Your answer should be very brief. 9.86. What is the difference between the highest and the lowest Balance of Payment (as % of service exports) of 2005?
Keep it short and to the point. 32.67. What is the difference between the highest and the lowest Balance of Payment (as % of service exports) of 2006?
Offer a very short reply. 30.19. What is the difference between the highest and the lowest Balance of Payment (as % of service exports) in 2007?
Give a very brief answer. 31.22. What is the difference between the highest and the lowest Balance of Payment (as % of service exports) of 2008?
Provide a succinct answer. 32.92. 